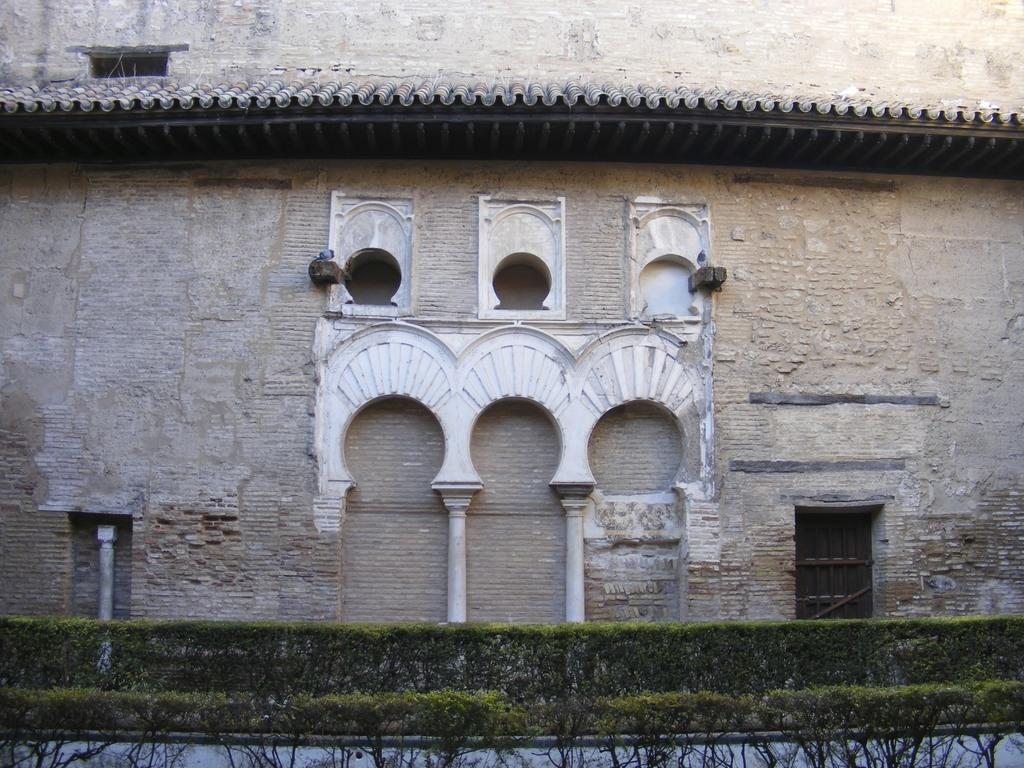What is located at the bottom of the image? There are plants and a road at the bottom of the image. What can be seen in the background of the image? There is a building and a bird in the background of the image. What type of approval does the bird in the image have? There is no indication of approval or disapproval in the image, as it features a bird in the background. How many cherries can be seen in the image? There are no cherries present in the image. 